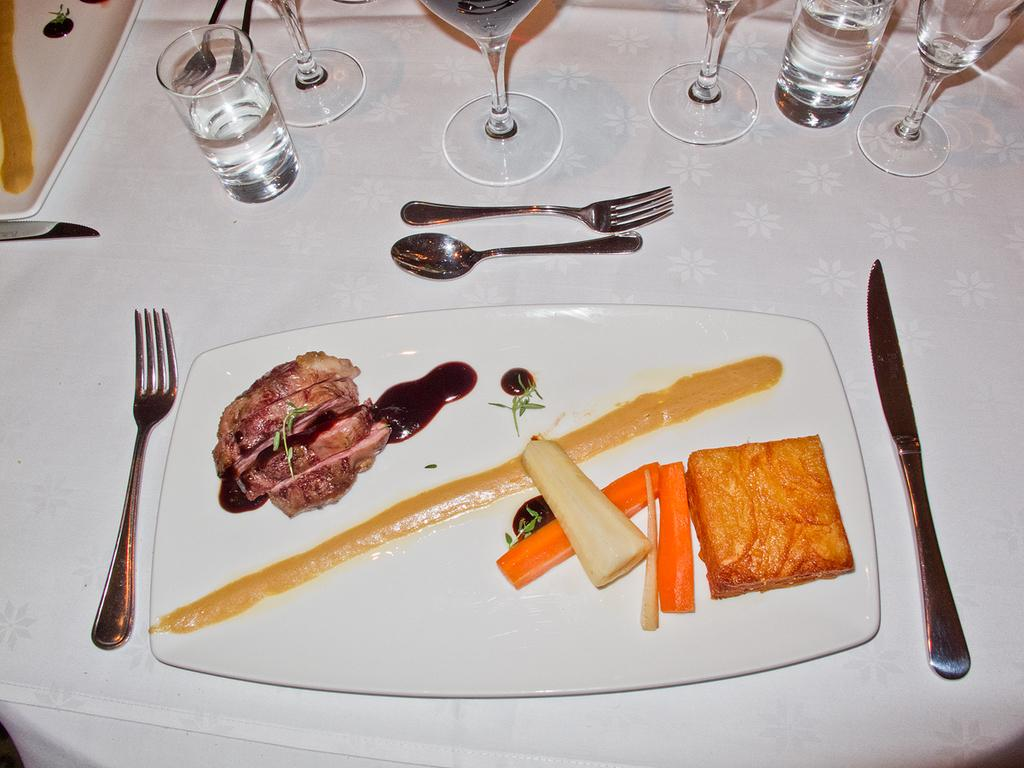What piece of furniture is present in the image? There is a table in the image. What utensils can be seen on the table? There is a fork, a spoon, and a knife on the table. What dishware is present on the table? There is a plate on the table. What type of food is visible on the table? There is a carrot and bread on the table. What beverage container is on the table? There is a glass on the table. What route does the tree take to reach the table in the image? There is no tree present in the image, so it cannot take a route to reach the table. 